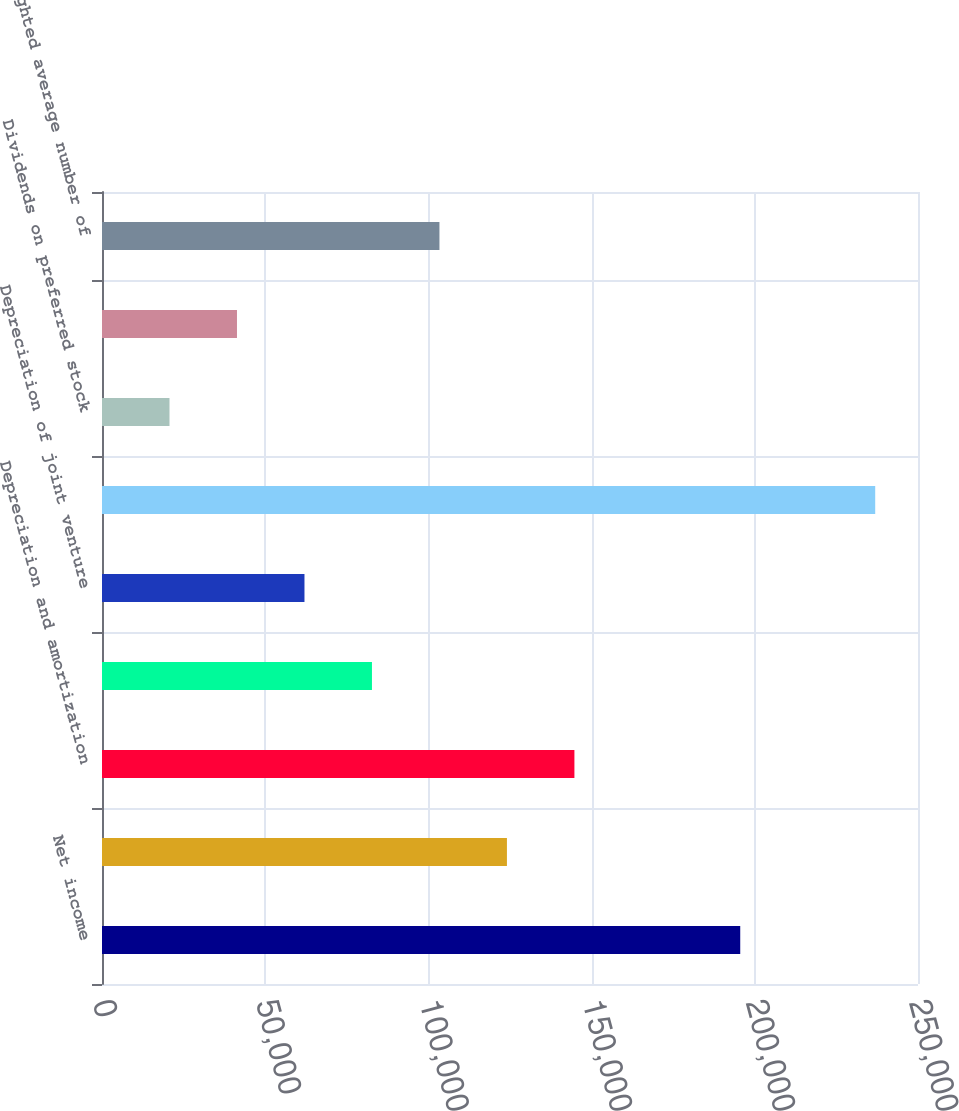<chart> <loc_0><loc_0><loc_500><loc_500><bar_chart><fcel>Net income<fcel>Gain on sale of real estate<fcel>Depreciation and amortization<fcel>Amortization of initial direct<fcel>Depreciation of joint venture<fcel>Funds from operations<fcel>Dividends on preferred stock<fcel>Income attributable to<fcel>Weighted average number of<nl><fcel>195537<fcel>124059<fcel>144735<fcel>82707<fcel>62031.2<fcel>236889<fcel>20679.5<fcel>41355.3<fcel>103383<nl></chart> 